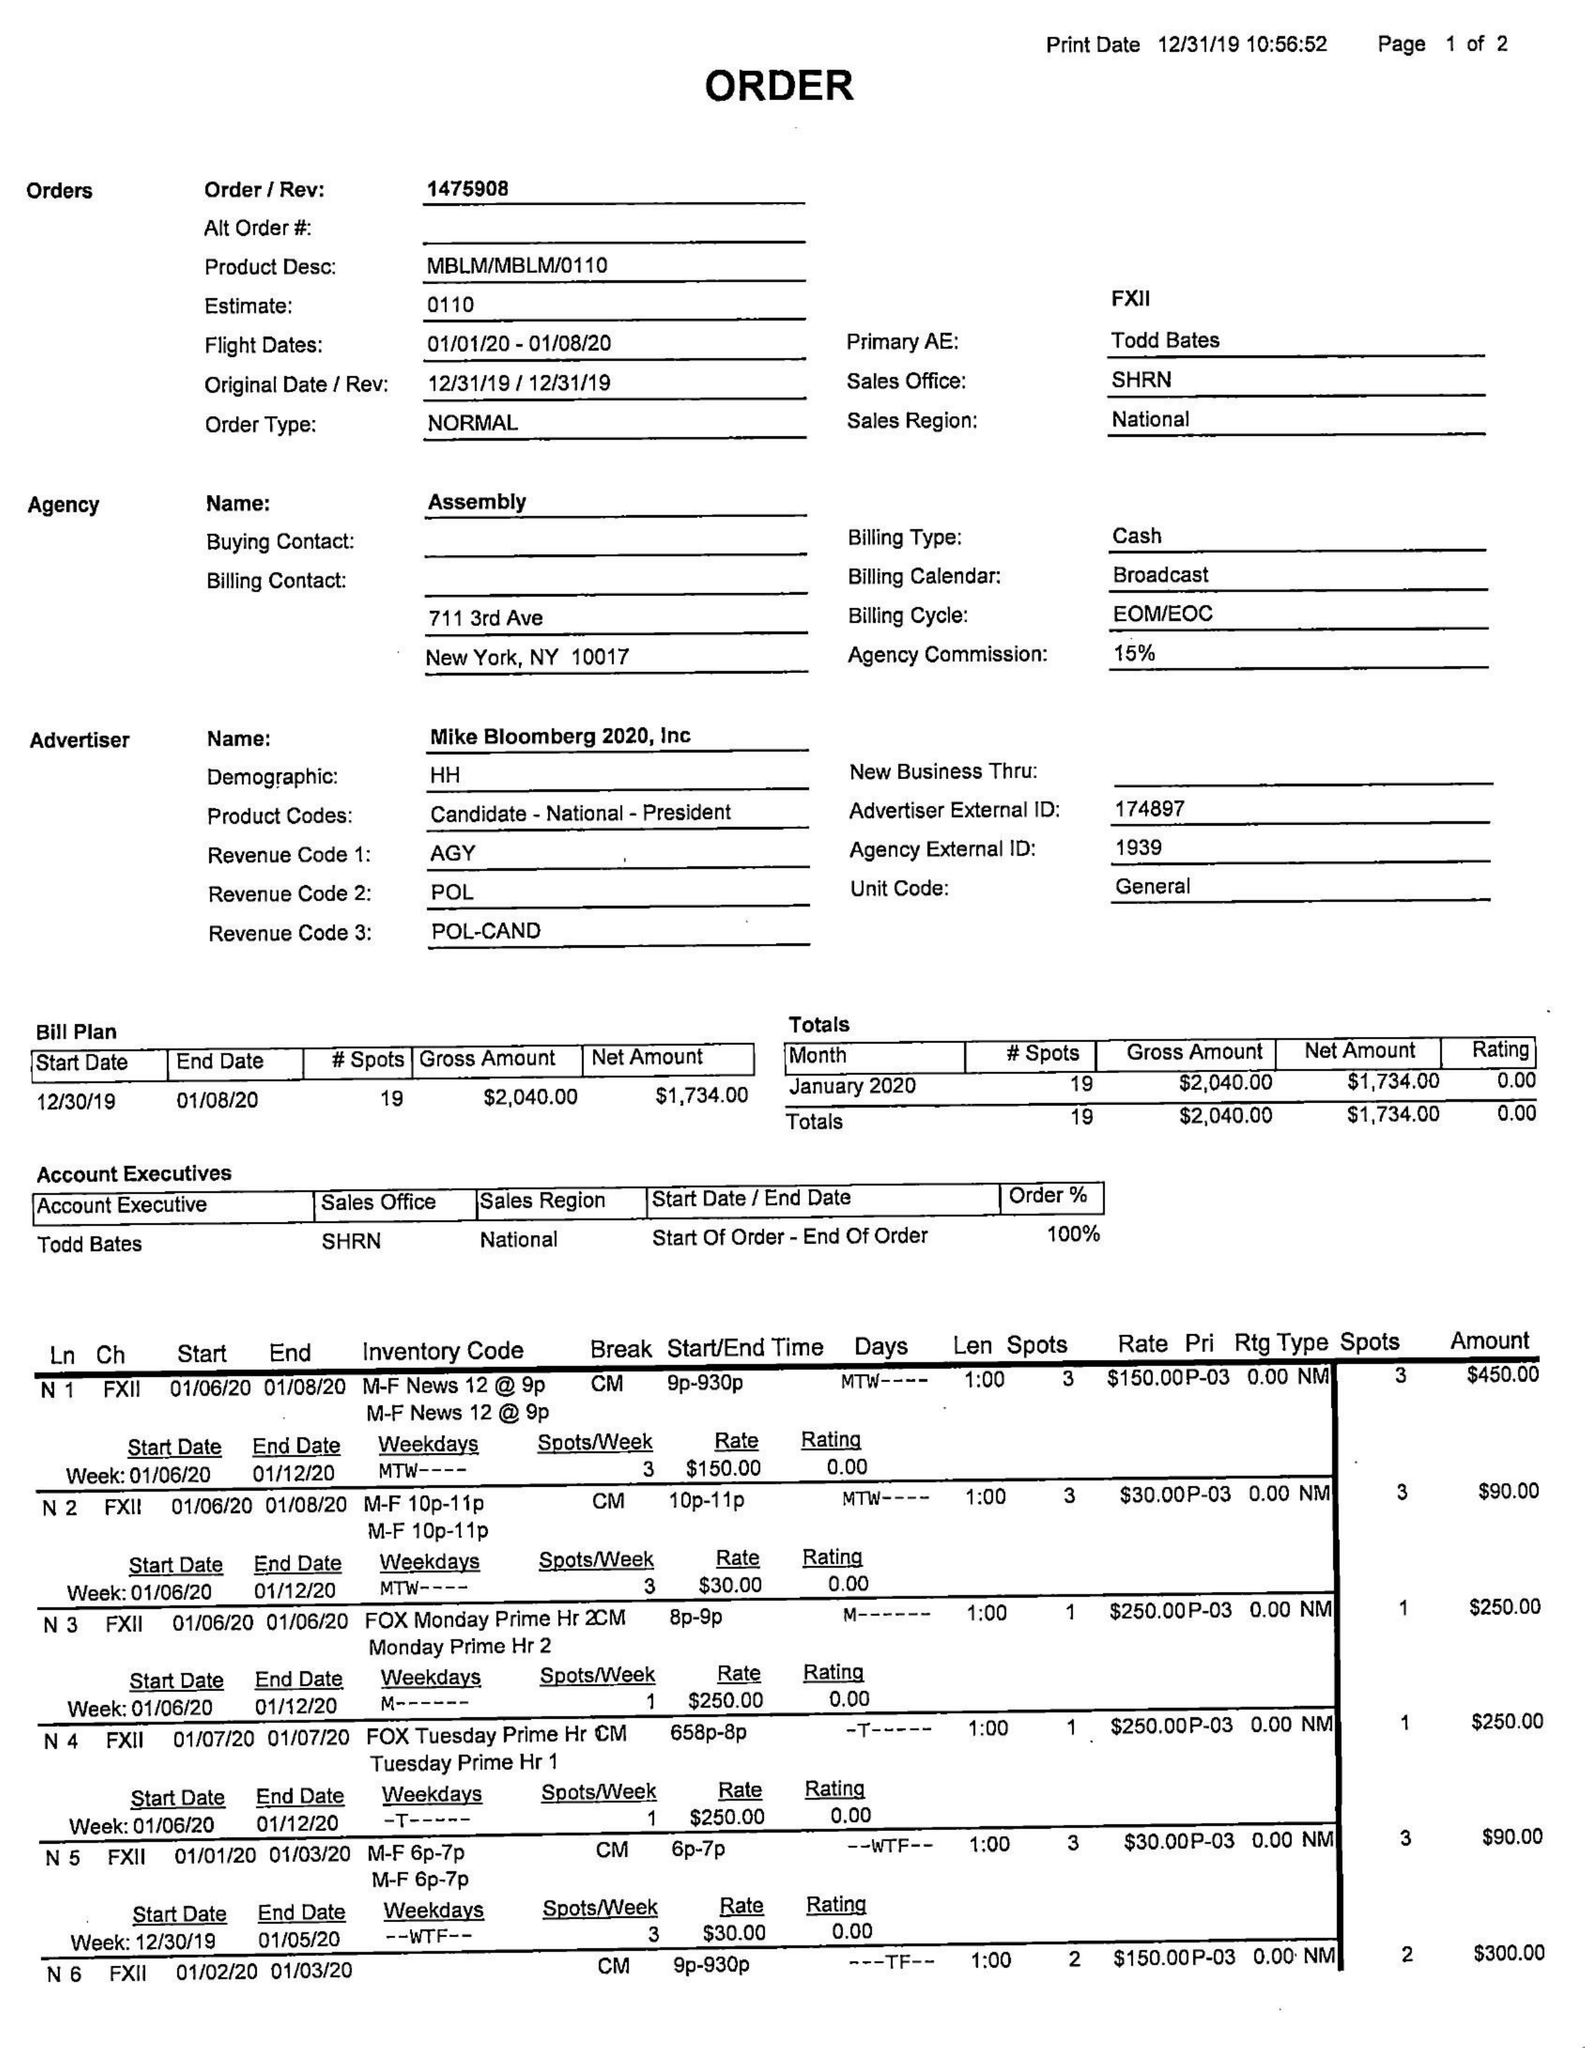What is the value for the advertiser?
Answer the question using a single word or phrase. MIKE BLOOMBERG 2020, INC 